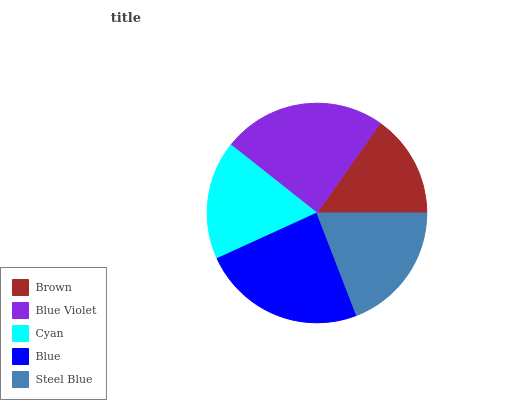Is Brown the minimum?
Answer yes or no. Yes. Is Blue Violet the maximum?
Answer yes or no. Yes. Is Cyan the minimum?
Answer yes or no. No. Is Cyan the maximum?
Answer yes or no. No. Is Blue Violet greater than Cyan?
Answer yes or no. Yes. Is Cyan less than Blue Violet?
Answer yes or no. Yes. Is Cyan greater than Blue Violet?
Answer yes or no. No. Is Blue Violet less than Cyan?
Answer yes or no. No. Is Steel Blue the high median?
Answer yes or no. Yes. Is Steel Blue the low median?
Answer yes or no. Yes. Is Blue the high median?
Answer yes or no. No. Is Cyan the low median?
Answer yes or no. No. 